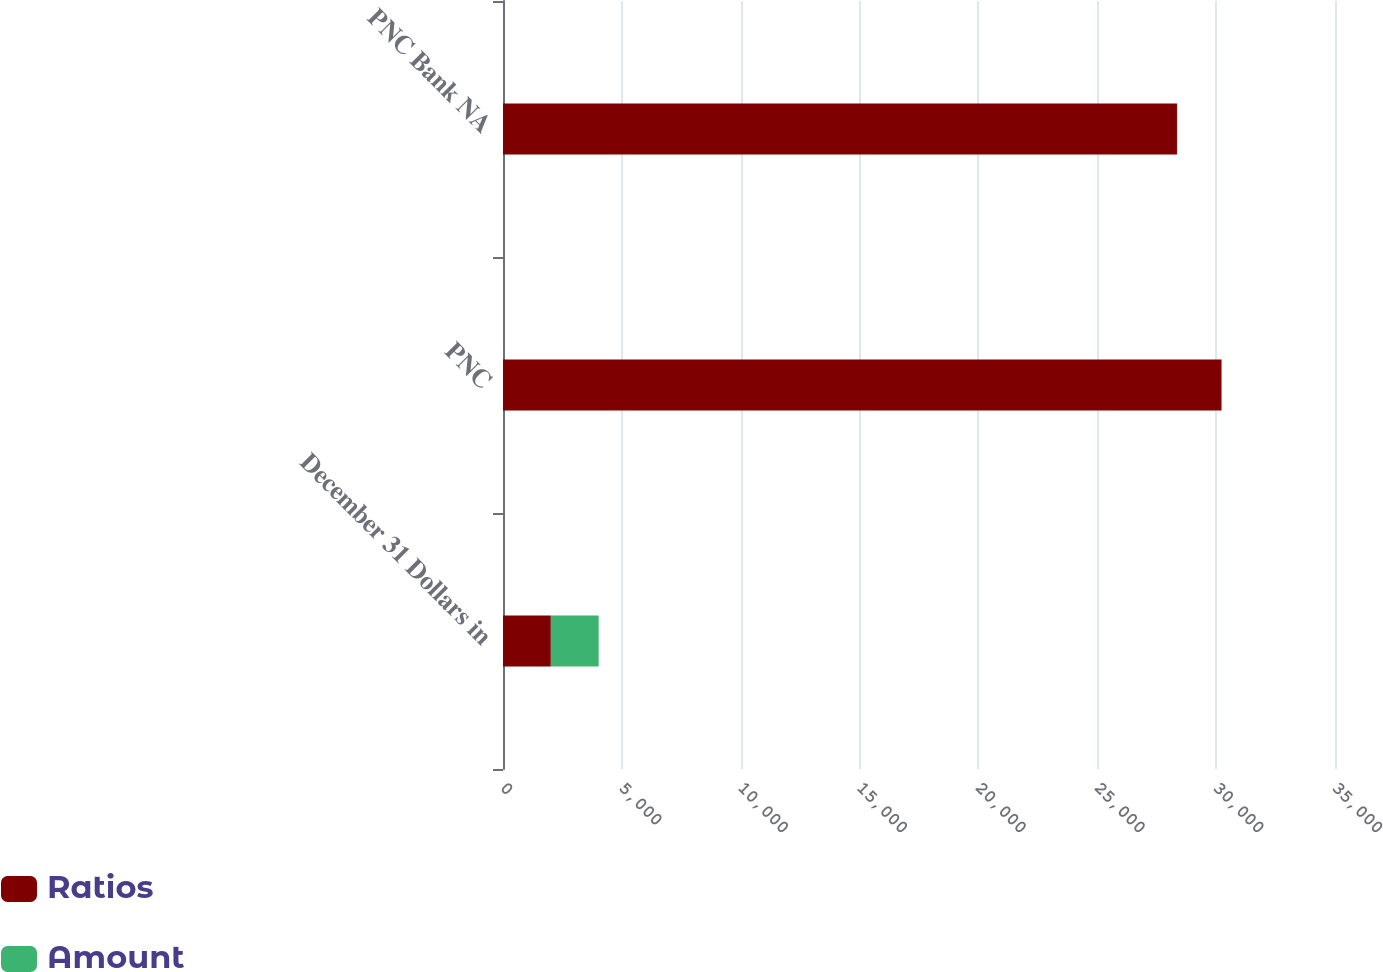Convert chart to OTSL. <chart><loc_0><loc_0><loc_500><loc_500><stacked_bar_chart><ecel><fcel>December 31 Dollars in<fcel>PNC<fcel>PNC Bank NA<nl><fcel>Ratios<fcel>2012<fcel>30226<fcel>28352<nl><fcel>Amount<fcel>2012<fcel>11.6<fcel>11.3<nl></chart> 